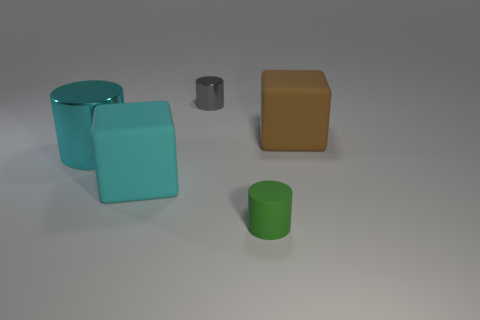Subtract all shiny cylinders. How many cylinders are left? 1 Add 1 large green balls. How many objects exist? 6 Subtract all blocks. How many objects are left? 3 Subtract all brown blocks. Subtract all cylinders. How many objects are left? 1 Add 4 big metallic things. How many big metallic things are left? 5 Add 5 brown rubber blocks. How many brown rubber blocks exist? 6 Subtract 0 brown cylinders. How many objects are left? 5 